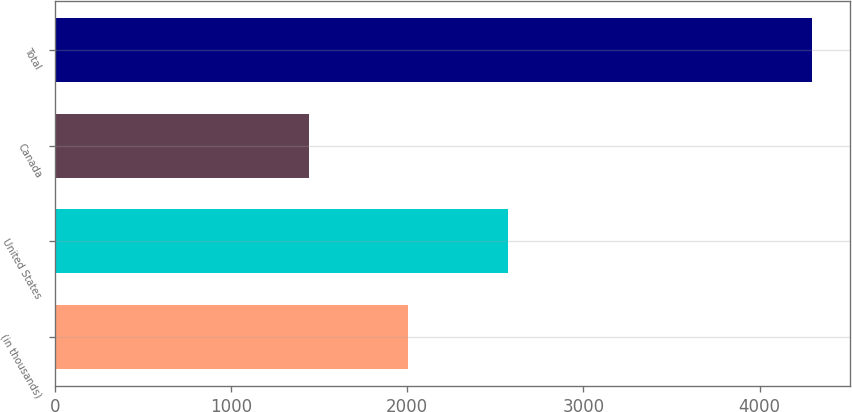<chart> <loc_0><loc_0><loc_500><loc_500><bar_chart><fcel>(in thousands)<fcel>United States<fcel>Canada<fcel>Total<nl><fcel>2005<fcel>2574<fcel>1442<fcel>4299<nl></chart> 